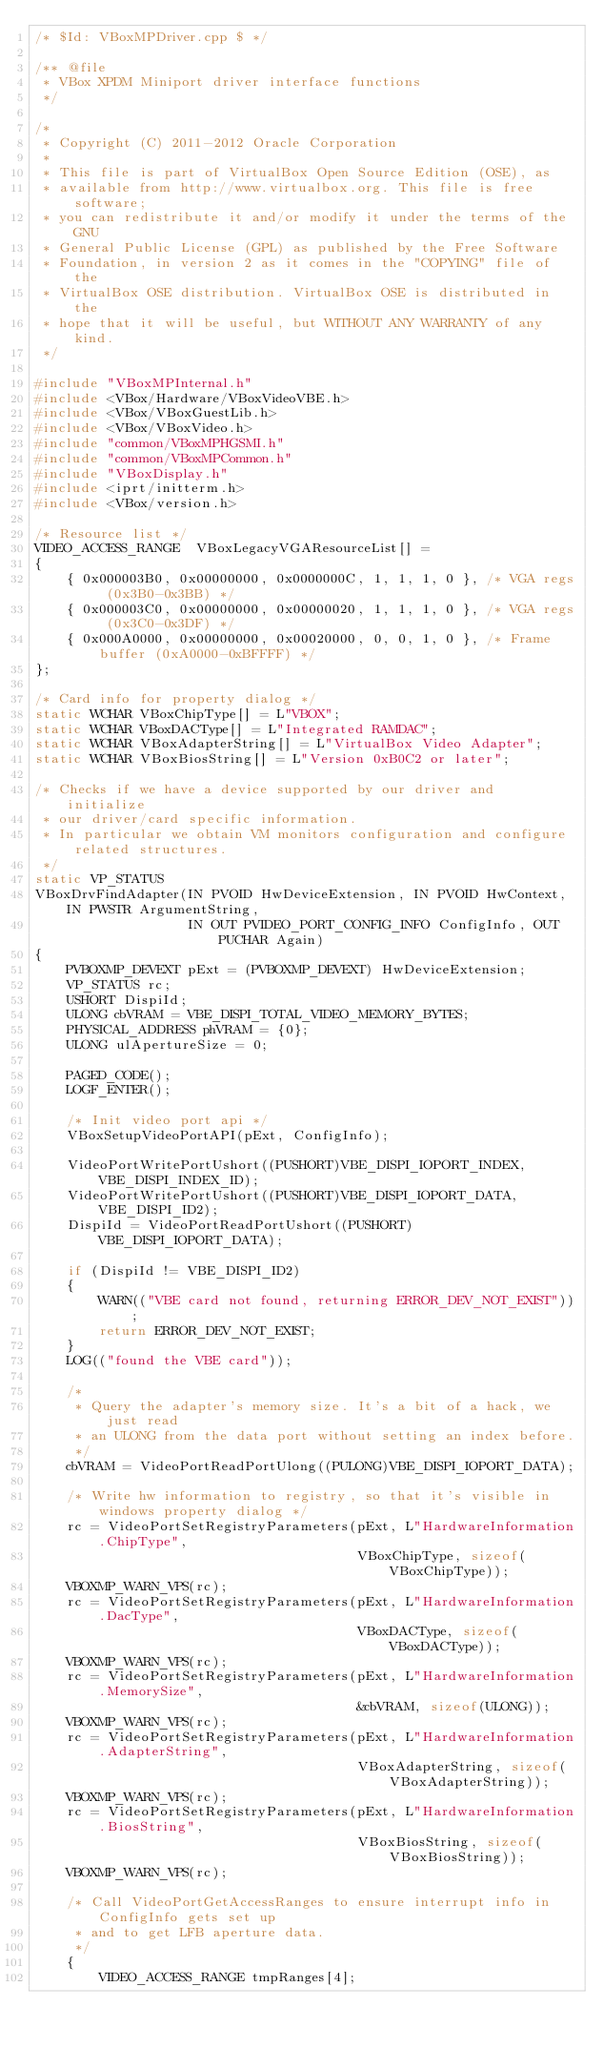<code> <loc_0><loc_0><loc_500><loc_500><_C++_>/* $Id: VBoxMPDriver.cpp $ */

/** @file
 * VBox XPDM Miniport driver interface functions
 */

/*
 * Copyright (C) 2011-2012 Oracle Corporation
 *
 * This file is part of VirtualBox Open Source Edition (OSE), as
 * available from http://www.virtualbox.org. This file is free software;
 * you can redistribute it and/or modify it under the terms of the GNU
 * General Public License (GPL) as published by the Free Software
 * Foundation, in version 2 as it comes in the "COPYING" file of the
 * VirtualBox OSE distribution. VirtualBox OSE is distributed in the
 * hope that it will be useful, but WITHOUT ANY WARRANTY of any kind.
 */

#include "VBoxMPInternal.h"
#include <VBox/Hardware/VBoxVideoVBE.h>
#include <VBox/VBoxGuestLib.h>
#include <VBox/VBoxVideo.h>
#include "common/VBoxMPHGSMI.h"
#include "common/VBoxMPCommon.h"
#include "VBoxDisplay.h"
#include <iprt/initterm.h>
#include <VBox/version.h>

/* Resource list */
VIDEO_ACCESS_RANGE  VBoxLegacyVGAResourceList[] =
{
    { 0x000003B0, 0x00000000, 0x0000000C, 1, 1, 1, 0 }, /* VGA regs (0x3B0-0x3BB) */
    { 0x000003C0, 0x00000000, 0x00000020, 1, 1, 1, 0 }, /* VGA regs (0x3C0-0x3DF) */
    { 0x000A0000, 0x00000000, 0x00020000, 0, 0, 1, 0 }, /* Frame buffer (0xA0000-0xBFFFF) */
};

/* Card info for property dialog */
static WCHAR VBoxChipType[] = L"VBOX";
static WCHAR VBoxDACType[] = L"Integrated RAMDAC";
static WCHAR VBoxAdapterString[] = L"VirtualBox Video Adapter";
static WCHAR VBoxBiosString[] = L"Version 0xB0C2 or later";

/* Checks if we have a device supported by our driver and initialize
 * our driver/card specific information.
 * In particular we obtain VM monitors configuration and configure related structures.
 */
static VP_STATUS
VBoxDrvFindAdapter(IN PVOID HwDeviceExtension, IN PVOID HwContext, IN PWSTR ArgumentString,
                   IN OUT PVIDEO_PORT_CONFIG_INFO ConfigInfo, OUT PUCHAR Again)
{
    PVBOXMP_DEVEXT pExt = (PVBOXMP_DEVEXT) HwDeviceExtension;
    VP_STATUS rc;
    USHORT DispiId;
    ULONG cbVRAM = VBE_DISPI_TOTAL_VIDEO_MEMORY_BYTES;
    PHYSICAL_ADDRESS phVRAM = {0};
    ULONG ulApertureSize = 0;

    PAGED_CODE();
    LOGF_ENTER();

    /* Init video port api */
    VBoxSetupVideoPortAPI(pExt, ConfigInfo);

    VideoPortWritePortUshort((PUSHORT)VBE_DISPI_IOPORT_INDEX, VBE_DISPI_INDEX_ID);
    VideoPortWritePortUshort((PUSHORT)VBE_DISPI_IOPORT_DATA, VBE_DISPI_ID2);
    DispiId = VideoPortReadPortUshort((PUSHORT)VBE_DISPI_IOPORT_DATA);

    if (DispiId != VBE_DISPI_ID2)
    {
        WARN(("VBE card not found, returning ERROR_DEV_NOT_EXIST"));
        return ERROR_DEV_NOT_EXIST;
    }
    LOG(("found the VBE card"));

    /*
     * Query the adapter's memory size. It's a bit of a hack, we just read
     * an ULONG from the data port without setting an index before.
     */
    cbVRAM = VideoPortReadPortUlong((PULONG)VBE_DISPI_IOPORT_DATA);

    /* Write hw information to registry, so that it's visible in windows property dialog */
    rc = VideoPortSetRegistryParameters(pExt, L"HardwareInformation.ChipType",
                                        VBoxChipType, sizeof(VBoxChipType));
    VBOXMP_WARN_VPS(rc);
    rc = VideoPortSetRegistryParameters(pExt, L"HardwareInformation.DacType",
                                        VBoxDACType, sizeof(VBoxDACType));
    VBOXMP_WARN_VPS(rc);
    rc = VideoPortSetRegistryParameters(pExt, L"HardwareInformation.MemorySize",
                                        &cbVRAM, sizeof(ULONG));
    VBOXMP_WARN_VPS(rc);
    rc = VideoPortSetRegistryParameters(pExt, L"HardwareInformation.AdapterString",
                                        VBoxAdapterString, sizeof(VBoxAdapterString));
    VBOXMP_WARN_VPS(rc);
    rc = VideoPortSetRegistryParameters(pExt, L"HardwareInformation.BiosString",
                                        VBoxBiosString, sizeof(VBoxBiosString));
    VBOXMP_WARN_VPS(rc);

    /* Call VideoPortGetAccessRanges to ensure interrupt info in ConfigInfo gets set up
     * and to get LFB aperture data.
     */
    {
        VIDEO_ACCESS_RANGE tmpRanges[4];</code> 